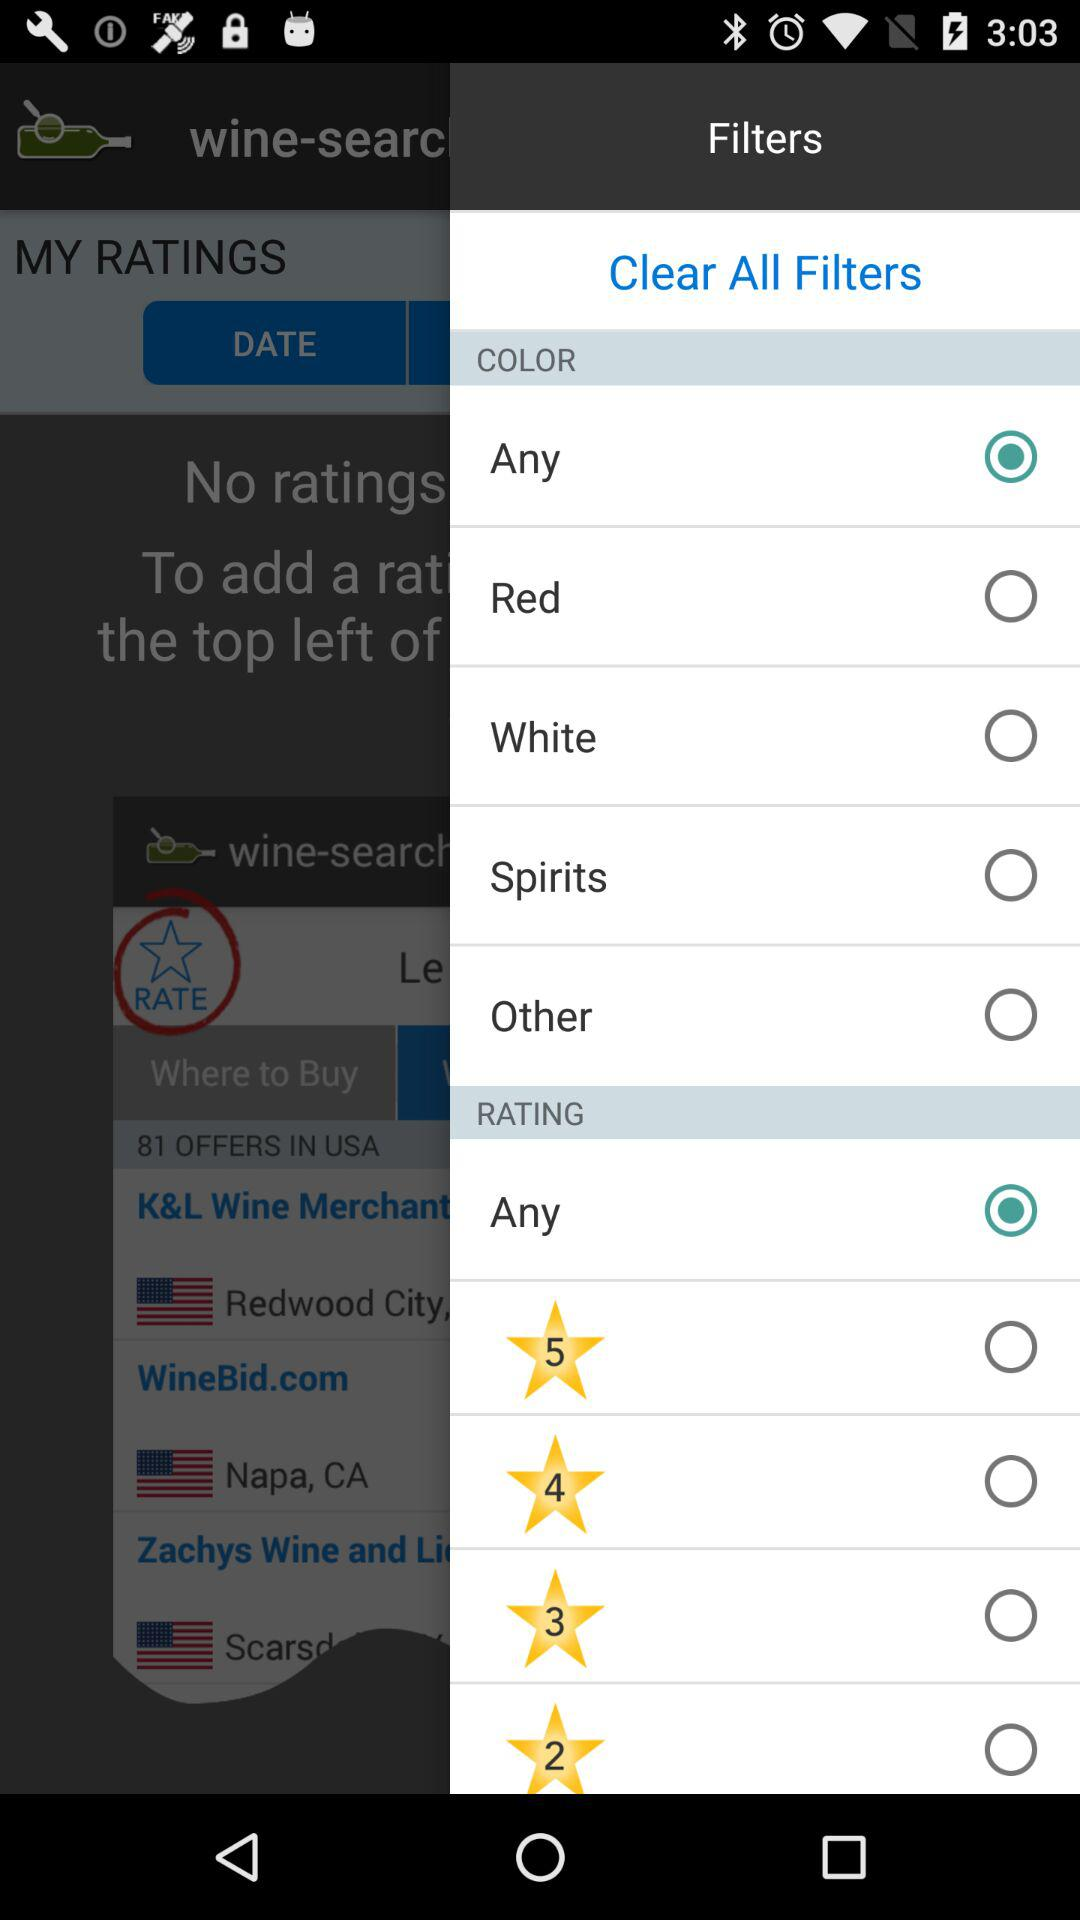What is the selected rating? The selected rating is "Any". 